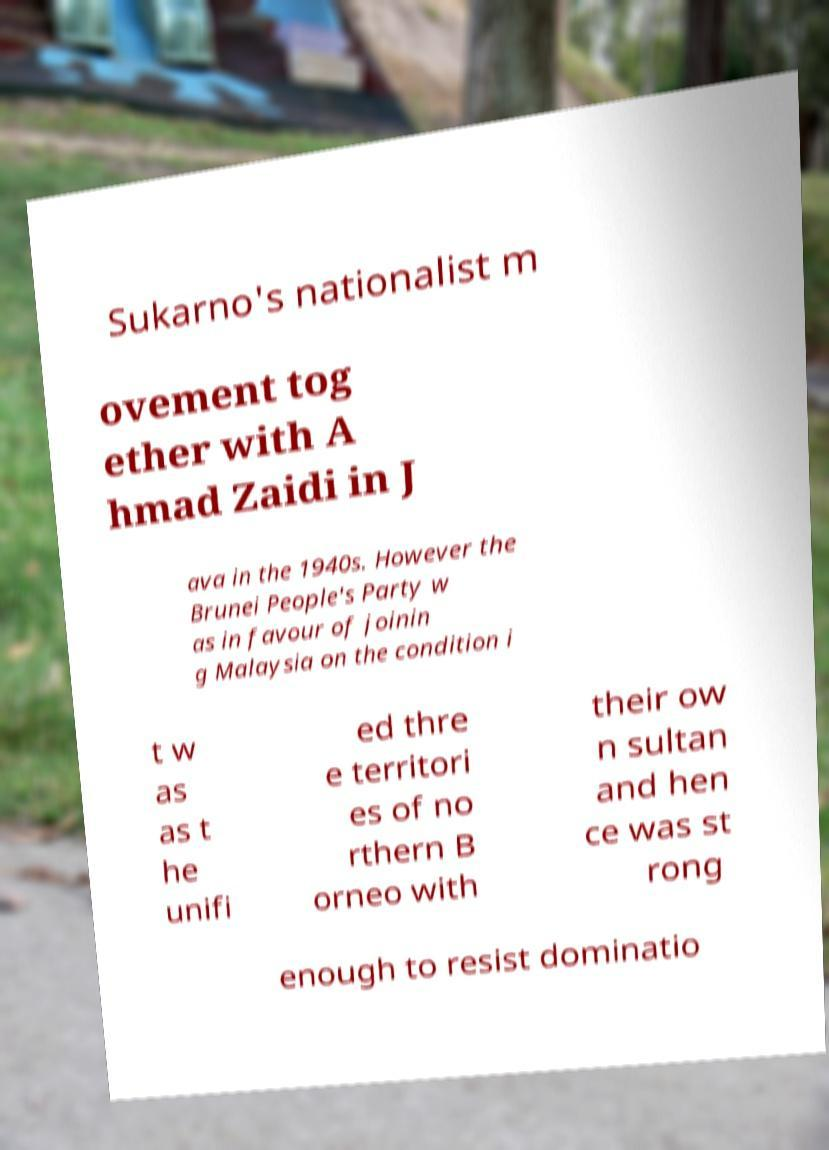Please identify and transcribe the text found in this image. Sukarno's nationalist m ovement tog ether with A hmad Zaidi in J ava in the 1940s. However the Brunei People's Party w as in favour of joinin g Malaysia on the condition i t w as as t he unifi ed thre e territori es of no rthern B orneo with their ow n sultan and hen ce was st rong enough to resist dominatio 